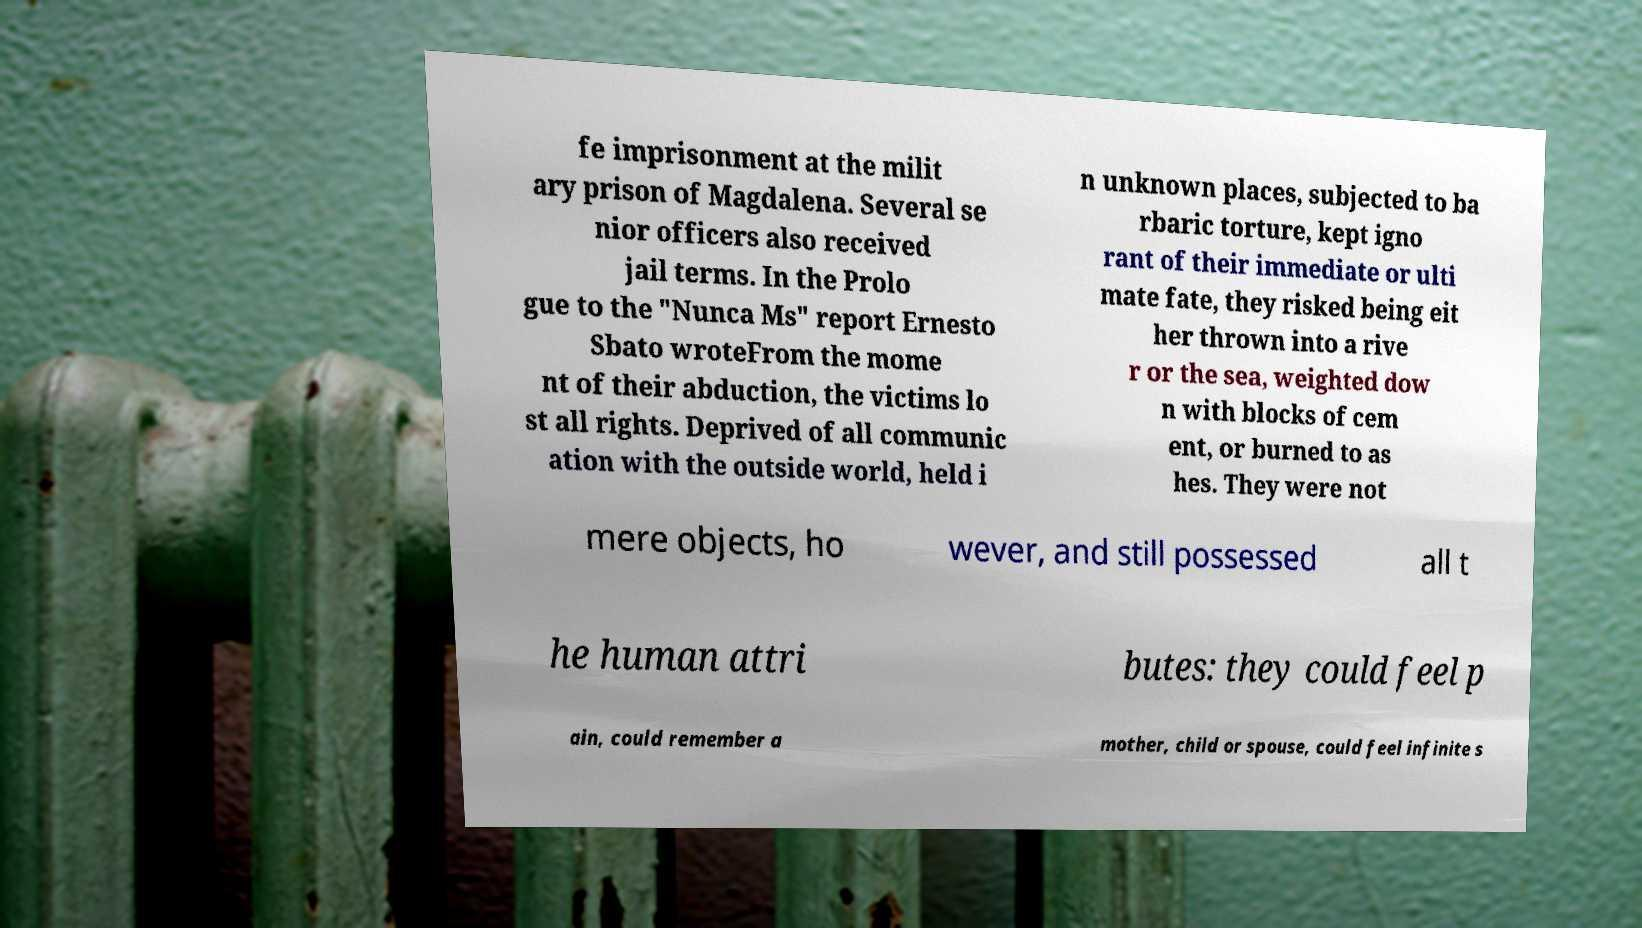Can you accurately transcribe the text from the provided image for me? fe imprisonment at the milit ary prison of Magdalena. Several se nior officers also received jail terms. In the Prolo gue to the "Nunca Ms" report Ernesto Sbato wroteFrom the mome nt of their abduction, the victims lo st all rights. Deprived of all communic ation with the outside world, held i n unknown places, subjected to ba rbaric torture, kept igno rant of their immediate or ulti mate fate, they risked being eit her thrown into a rive r or the sea, weighted dow n with blocks of cem ent, or burned to as hes. They were not mere objects, ho wever, and still possessed all t he human attri butes: they could feel p ain, could remember a mother, child or spouse, could feel infinite s 